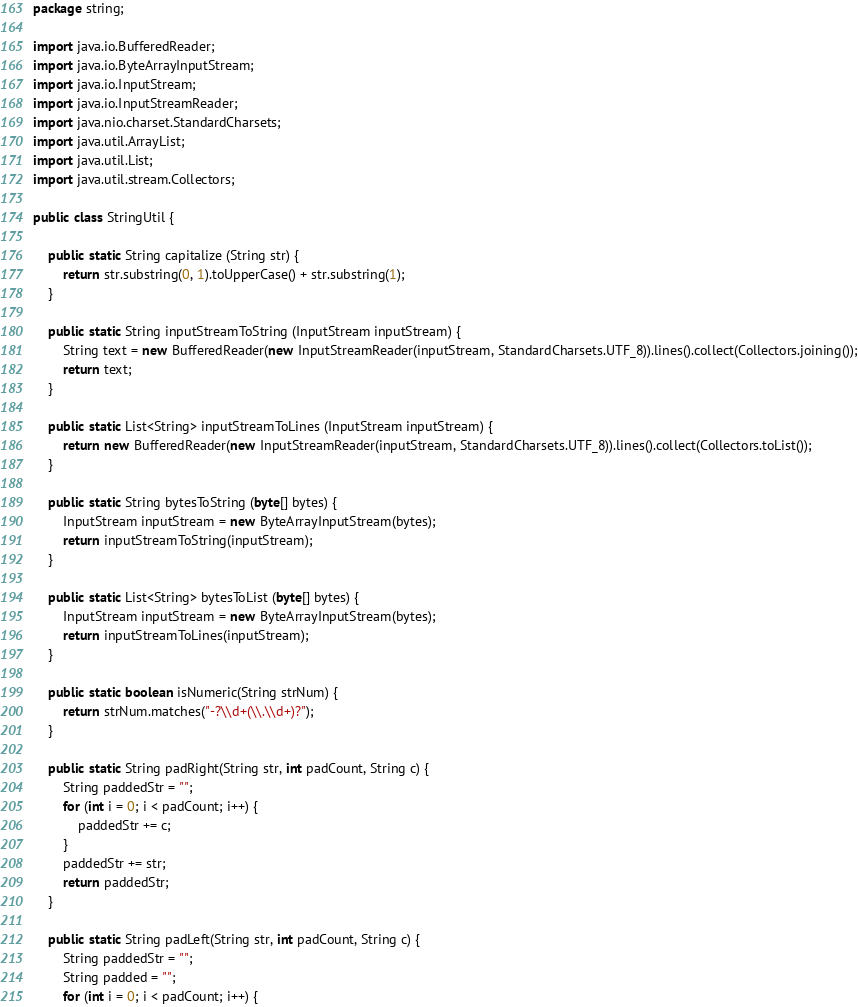<code> <loc_0><loc_0><loc_500><loc_500><_Java_>package string;

import java.io.BufferedReader;
import java.io.ByteArrayInputStream;
import java.io.InputStream;
import java.io.InputStreamReader;
import java.nio.charset.StandardCharsets;
import java.util.ArrayList;
import java.util.List;
import java.util.stream.Collectors;

public class StringUtil {

    public static String capitalize (String str) {
        return str.substring(0, 1).toUpperCase() + str.substring(1);
    }

    public static String inputStreamToString (InputStream inputStream) {
        String text = new BufferedReader(new InputStreamReader(inputStream, StandardCharsets.UTF_8)).lines().collect(Collectors.joining());
        return text;
    }

    public static List<String> inputStreamToLines (InputStream inputStream) {
        return new BufferedReader(new InputStreamReader(inputStream, StandardCharsets.UTF_8)).lines().collect(Collectors.toList());
    }

    public static String bytesToString (byte[] bytes) {
        InputStream inputStream = new ByteArrayInputStream(bytes);
        return inputStreamToString(inputStream);
    }

    public static List<String> bytesToList (byte[] bytes) {
        InputStream inputStream = new ByteArrayInputStream(bytes);
        return inputStreamToLines(inputStream);
    }

    public static boolean isNumeric(String strNum) {
        return strNum.matches("-?\\d+(\\.\\d+)?");
    }

    public static String padRight(String str, int padCount, String c) {
        String paddedStr = "";
        for (int i = 0; i < padCount; i++) {
            paddedStr += c;
        }
        paddedStr += str;
        return paddedStr;
    }

    public static String padLeft(String str, int padCount, String c) {
        String paddedStr = "";
        String padded = "";
        for (int i = 0; i < padCount; i++) {</code> 